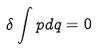<formula> <loc_0><loc_0><loc_500><loc_500>\delta \int p d q = 0</formula> 